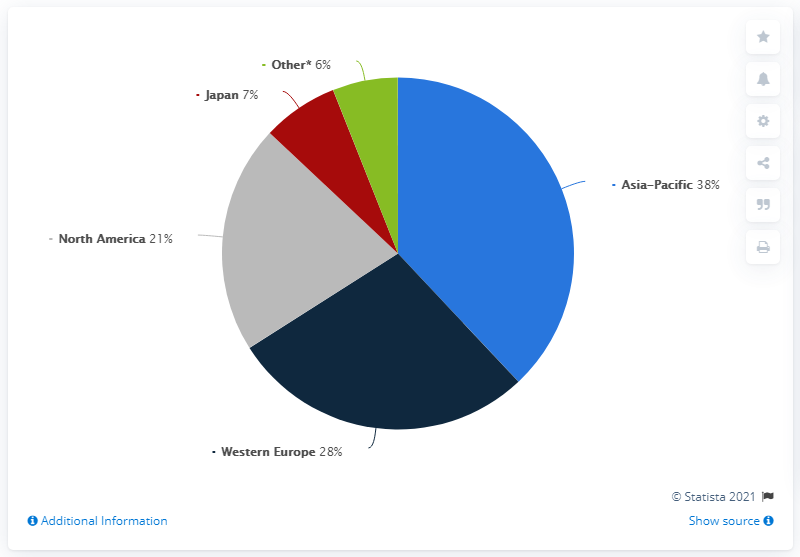Give some essential details in this illustration. The sum of North America and Western Europe is 49. The red color in the pie chart represents Japan. 